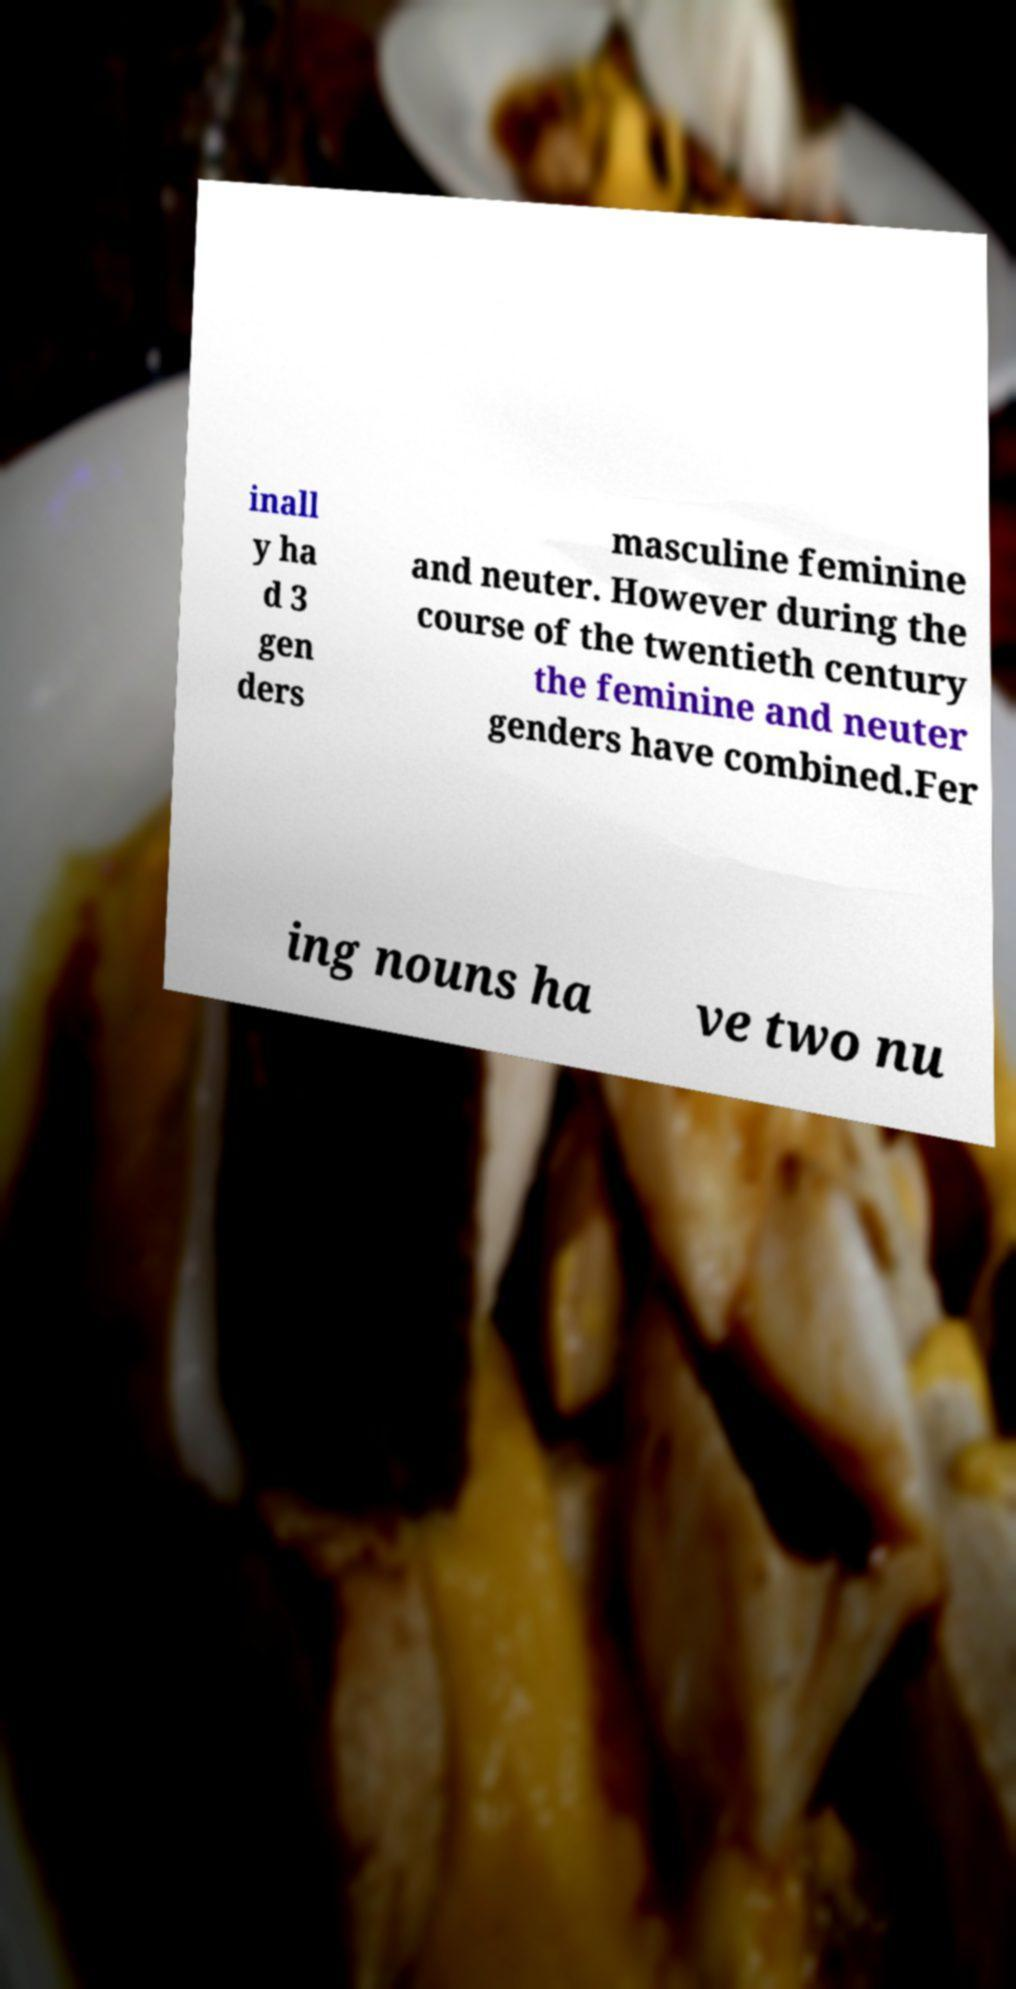Please read and relay the text visible in this image. What does it say? inall y ha d 3 gen ders masculine feminine and neuter. However during the course of the twentieth century the feminine and neuter genders have combined.Fer ing nouns ha ve two nu 